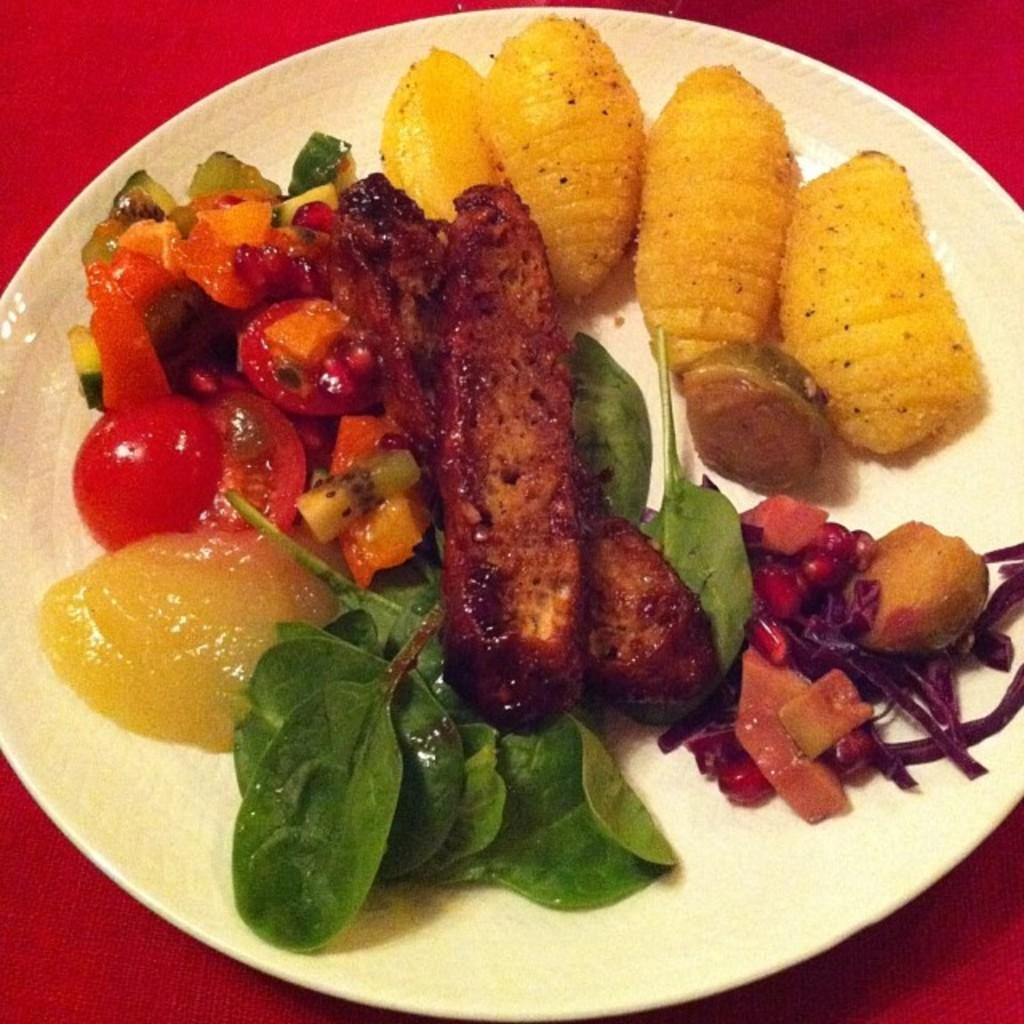What type of vegetation can be seen in the image? There are leaves in the image. What else is present in the image besides the leaves? There are other food items in the image. What color is the plate that holds the food items? The plate is white in color. How many queens are present in the image? There are no queens present in the image. What number is written on the plate in the image? There is no number written on the plate in the image. 